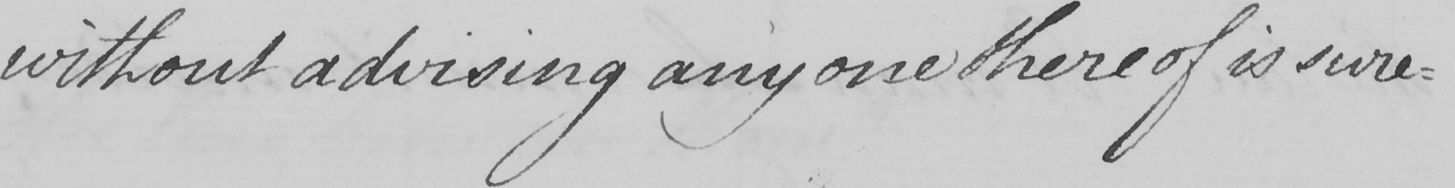Transcribe the text shown in this historical manuscript line. without advising any one there of is sure- 